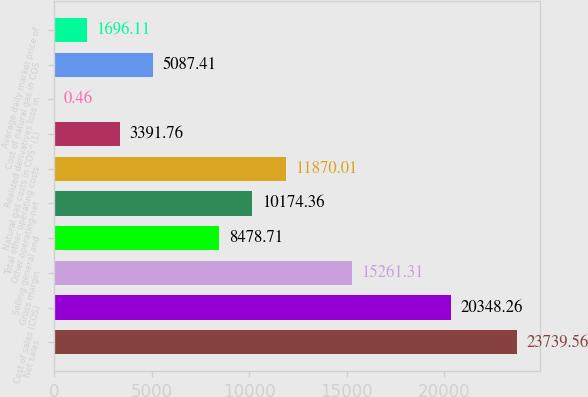Convert chart to OTSL. <chart><loc_0><loc_0><loc_500><loc_500><bar_chart><fcel>Net sales<fcel>Cost of sales (COS)<fcel>Gross margin<fcel>Selling general and<fcel>Other operating-net<fcel>Total other operating costs<fcel>Natural gas costs in COS^(1)<fcel>Realized derivatives loss in<fcel>Cost of natural gas in COS<fcel>Average daily market price of<nl><fcel>23739.6<fcel>20348.3<fcel>15261.3<fcel>8478.71<fcel>10174.4<fcel>11870<fcel>3391.76<fcel>0.46<fcel>5087.41<fcel>1696.11<nl></chart> 